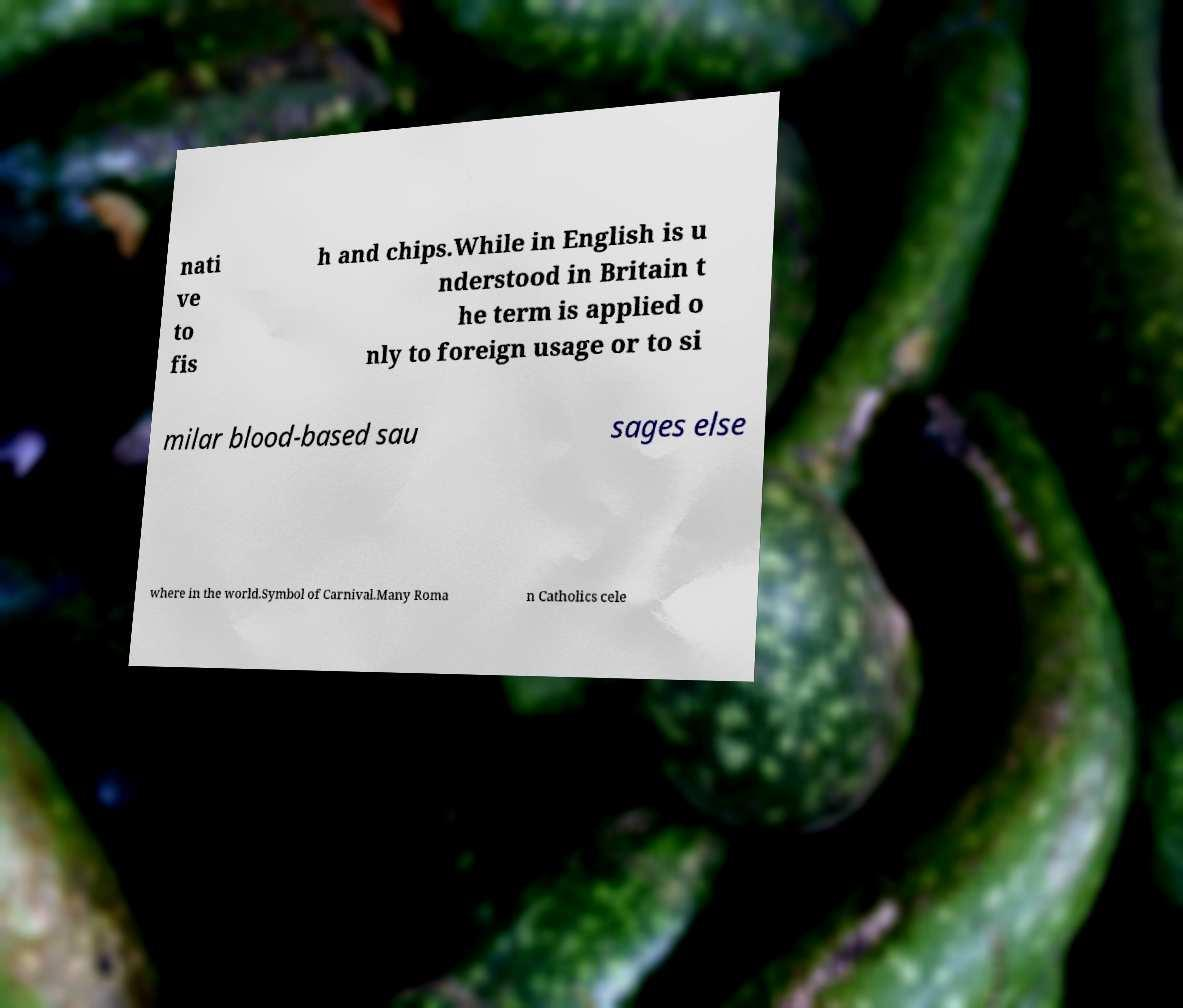For documentation purposes, I need the text within this image transcribed. Could you provide that? nati ve to fis h and chips.While in English is u nderstood in Britain t he term is applied o nly to foreign usage or to si milar blood-based sau sages else where in the world.Symbol of Carnival.Many Roma n Catholics cele 